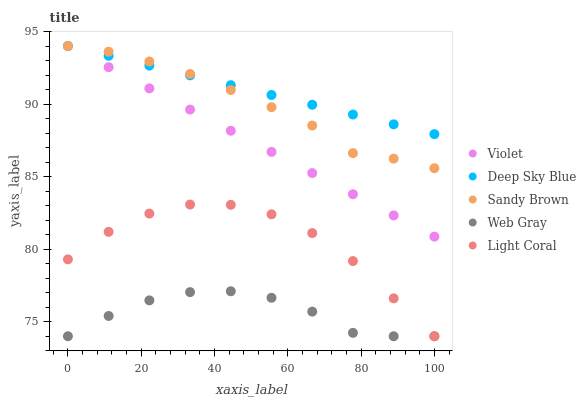Does Web Gray have the minimum area under the curve?
Answer yes or no. Yes. Does Deep Sky Blue have the maximum area under the curve?
Answer yes or no. Yes. Does Sandy Brown have the minimum area under the curve?
Answer yes or no. No. Does Sandy Brown have the maximum area under the curve?
Answer yes or no. No. Is Violet the smoothest?
Answer yes or no. Yes. Is Light Coral the roughest?
Answer yes or no. Yes. Is Web Gray the smoothest?
Answer yes or no. No. Is Web Gray the roughest?
Answer yes or no. No. Does Light Coral have the lowest value?
Answer yes or no. Yes. Does Sandy Brown have the lowest value?
Answer yes or no. No. Does Violet have the highest value?
Answer yes or no. Yes. Does Web Gray have the highest value?
Answer yes or no. No. Is Web Gray less than Deep Sky Blue?
Answer yes or no. Yes. Is Violet greater than Light Coral?
Answer yes or no. Yes. Does Violet intersect Sandy Brown?
Answer yes or no. Yes. Is Violet less than Sandy Brown?
Answer yes or no. No. Is Violet greater than Sandy Brown?
Answer yes or no. No. Does Web Gray intersect Deep Sky Blue?
Answer yes or no. No. 